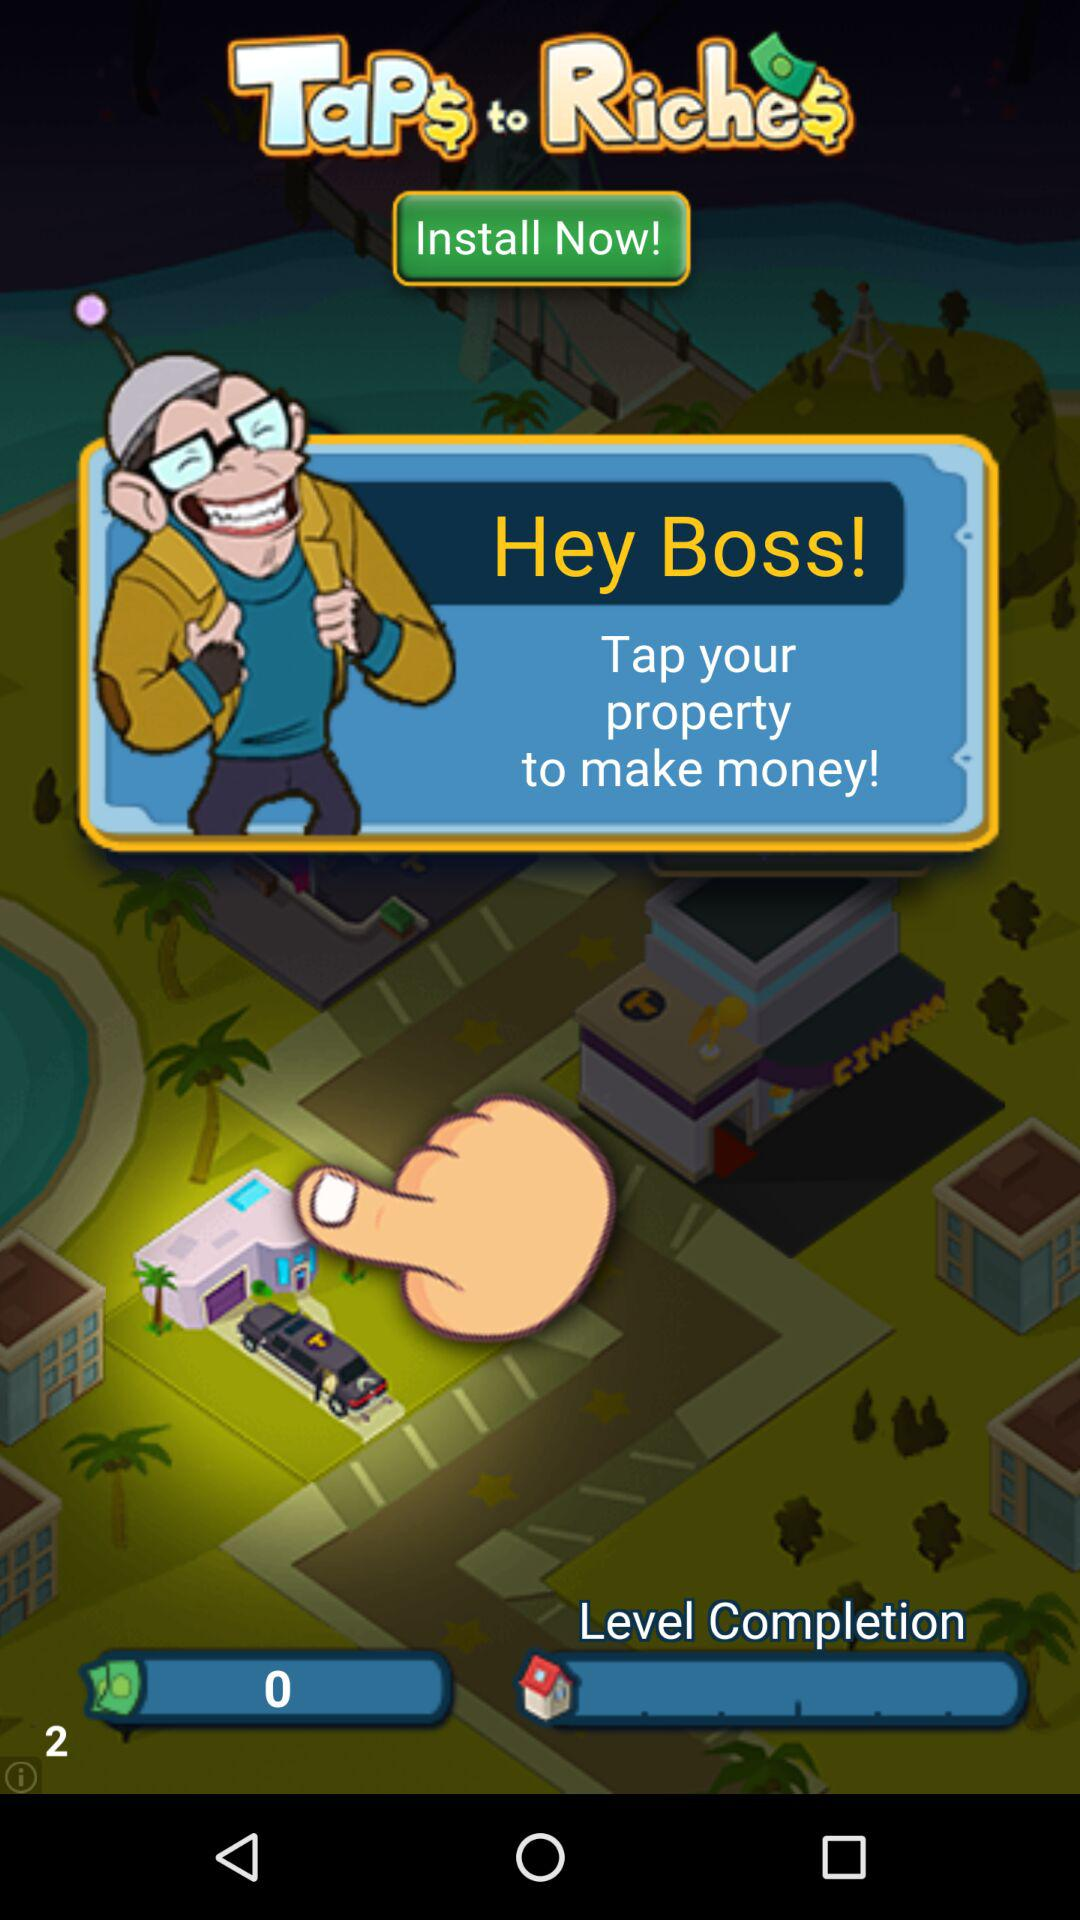How many levels have been completed?
Answer the question using a single word or phrase. 2 